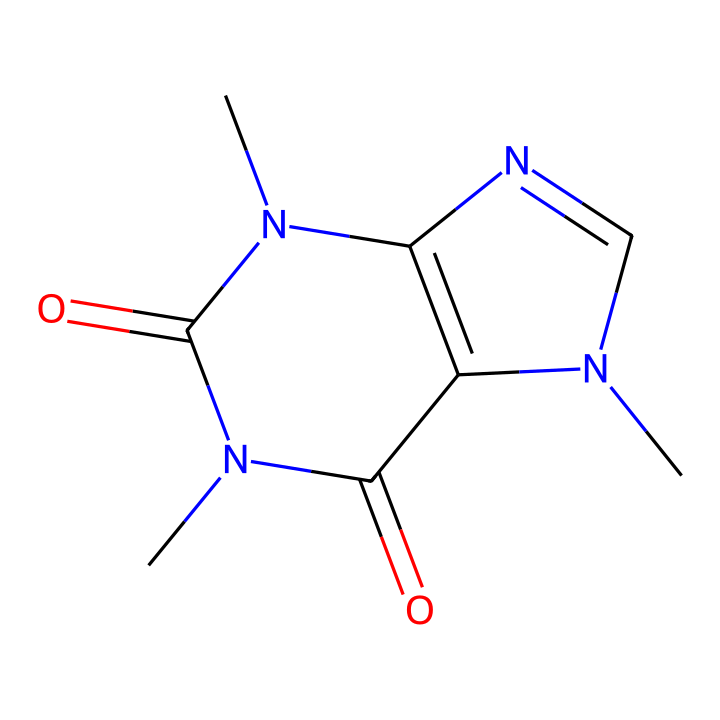how many carbon atoms are in the structure? By analyzing the SMILES representation, we look for 'C' which denotes carbon atoms. Counting the instances gives a total of 8 carbon atoms.
Answer: 8 what is the molecular formula of caffeine based on its structure? By extracting the atom counts from the SMILES: 8 carbon (C), 10 hydrogen (H), 4 nitrogen (N), and 4 oxygen (O). This gives the molecular formula C8H10N4O2.
Answer: C8H10N4O2 how many double bonds are present in the structure? In the SMILES representation, double bonds are indicated by '='. Scanning through the structure reveals 2 double bonds.
Answer: 2 does the structure have geometric isomers? The presence of nitrogen and carbon in the ring structure suggests the possibility of geometric isomers due to the arrangement of atoms around the double bonds.
Answer: yes what type of geometric isomerism can occur in this structure? Since the molecule contains double-bonded carbons in a cyclic configuration, it can exhibit cis-trans isomerism depending on the orientation of substituents around the double bonds.
Answer: cis-trans what is the significance of or groups in the caffeine structure? The presence of amine groups (N atoms) in caffeine structure is important for its biological activity as a stimulant, which enhances alertness and reduces fatigue, particularly during soccer matches.
Answer: stimulant how many rings are there in the structure? The SMILES reveals a fused ring system; counting the distinct cyclic components indicates there are 2 rings in the structure of caffeine.
Answer: 2 